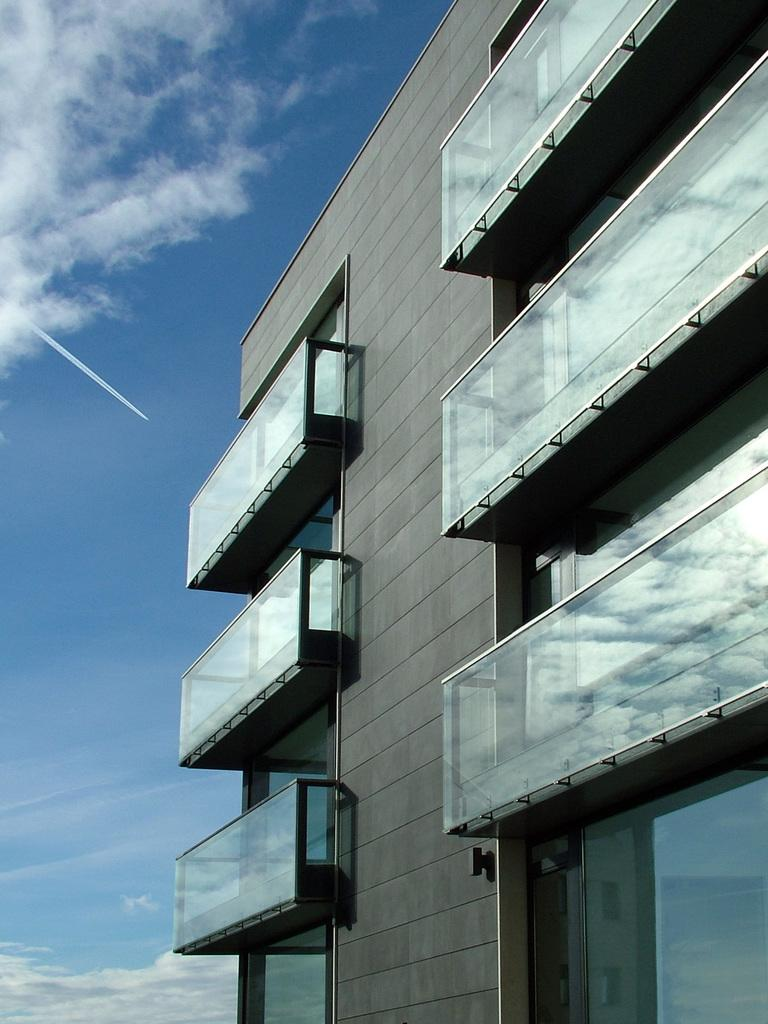What type of structure is visible in the image? There is a building in the image. What material is used for the window of the building? The building has a glass window. What type of fencing is present around the building? The building has glass fencing. What color is the building in the image? The building is in ash color. What colors can be seen in the sky in the image? The sky is blue and white in color. Can you see a metal boat in the image? There is no boat, metal or otherwise, present in the image. Are there any seats visible in the image? There are no seats visible in the image; the focus is on the building and the sky. 